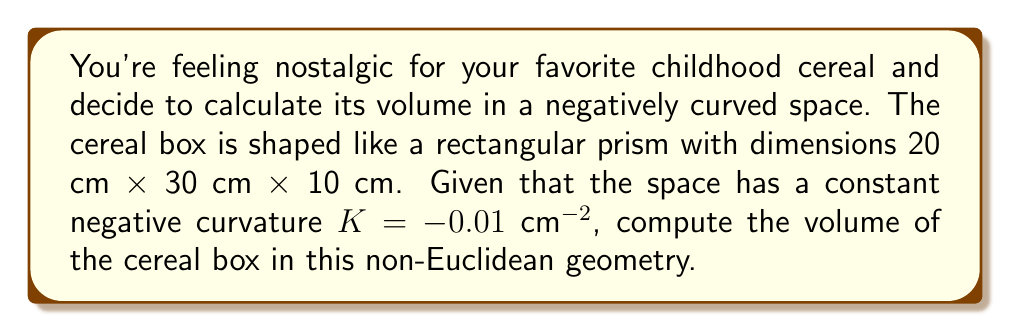What is the answer to this math problem? To solve this problem, we'll use the formula for the volume of a rectangular prism in a space with constant negative curvature $K$. The formula is:

$$V = \frac{8}{|K|^{3/2}} \left(\sinh\left(\frac{\sqrt{|K|}a}{2}\right) \sinh\left(\frac{\sqrt{|K|}b}{2}\right) \sinh\left(\frac{\sqrt{|K|}c}{2}\right)\right)$$

Where $a$, $b$, and $c$ are the dimensions of the rectangular prism.

Step 1: Identify the given values
$a = 20$ cm
$b = 30$ cm
$c = 10$ cm
$K = -0.01$ $\text{cm}^{-2}$

Step 2: Calculate $\sqrt{|K|}$
$\sqrt{|K|} = \sqrt{0.01} = 0.1$ $\text{cm}^{-1}$

Step 3: Calculate the arguments of the sinh functions
$\frac{\sqrt{|K|}a}{2} = \frac{0.1 \times 20}{2} = 1$
$\frac{\sqrt{|K|}b}{2} = \frac{0.1 \times 30}{2} = 1.5$
$\frac{\sqrt{|K|}c}{2} = \frac{0.1 \times 10}{2} = 0.5$

Step 4: Calculate the sinh values
$\sinh(1) \approx 1.1752$
$\sinh(1.5) \approx 2.1293$
$\sinh(0.5) \approx 0.5211$

Step 5: Substitute all values into the volume formula
$$V = \frac{8}{(0.01)^{3/2}} (1.1752 \times 2.1293 \times 0.5211)$$

Step 6: Simplify and calculate the final volume
$$V = 8000 \times 1.3033 = 10426.4 \text{ cm}^3$$
Answer: $10426.4 \text{ cm}^3$ 